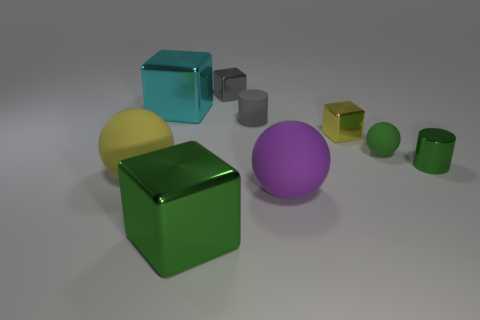What is the material of the cube that is the same color as the metal cylinder?
Your answer should be compact. Metal. What number of green metallic objects are on the right side of the small matte sphere and in front of the purple rubber ball?
Ensure brevity in your answer.  0. What number of other objects are the same color as the metal cylinder?
Ensure brevity in your answer.  2. What number of gray objects are big metal cylinders or small shiny things?
Your response must be concise. 1. What is the size of the purple thing?
Offer a very short reply. Large. How many matte things are green cylinders or small objects?
Provide a succinct answer. 2. Are there fewer tiny green balls than large objects?
Offer a very short reply. Yes. What number of other objects are the same material as the tiny green cylinder?
Provide a succinct answer. 4. There is a green rubber thing that is the same shape as the large yellow thing; what is its size?
Ensure brevity in your answer.  Small. Is the material of the yellow object that is right of the big green cube the same as the large ball that is on the right side of the cyan block?
Give a very brief answer. No. 